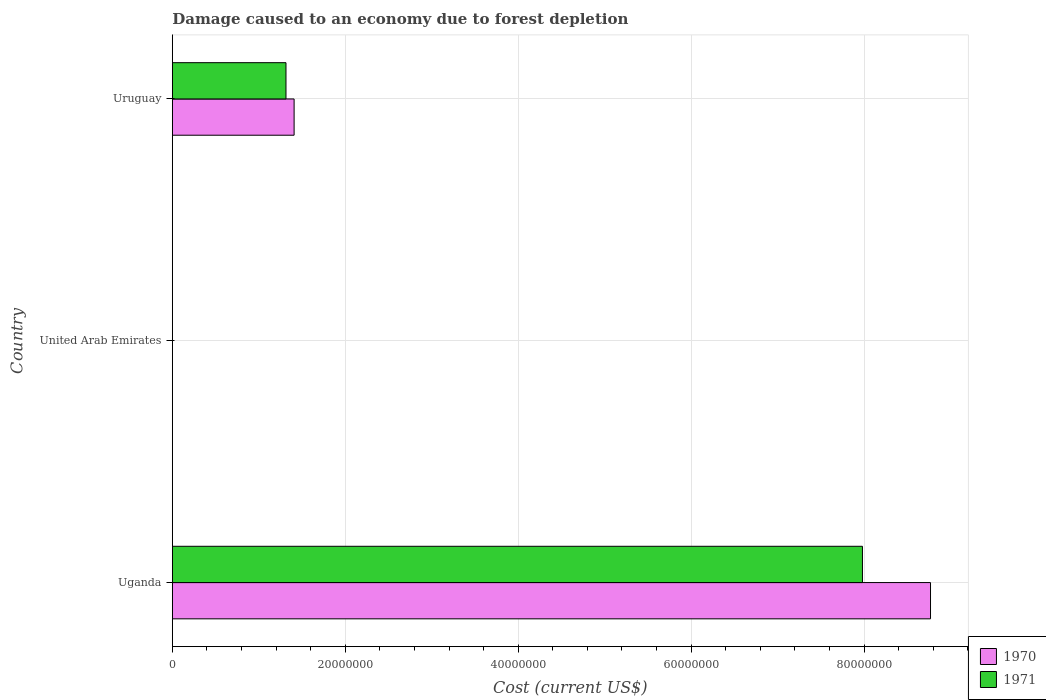Are the number of bars per tick equal to the number of legend labels?
Provide a succinct answer. Yes. Are the number of bars on each tick of the Y-axis equal?
Your answer should be very brief. Yes. How many bars are there on the 1st tick from the top?
Keep it short and to the point. 2. How many bars are there on the 2nd tick from the bottom?
Make the answer very short. 2. What is the label of the 2nd group of bars from the top?
Give a very brief answer. United Arab Emirates. In how many cases, is the number of bars for a given country not equal to the number of legend labels?
Give a very brief answer. 0. What is the cost of damage caused due to forest depletion in 1971 in Uganda?
Offer a terse response. 7.98e+07. Across all countries, what is the maximum cost of damage caused due to forest depletion in 1971?
Make the answer very short. 7.98e+07. Across all countries, what is the minimum cost of damage caused due to forest depletion in 1970?
Give a very brief answer. 5907.56. In which country was the cost of damage caused due to forest depletion in 1970 maximum?
Provide a short and direct response. Uganda. In which country was the cost of damage caused due to forest depletion in 1971 minimum?
Provide a short and direct response. United Arab Emirates. What is the total cost of damage caused due to forest depletion in 1971 in the graph?
Offer a terse response. 9.30e+07. What is the difference between the cost of damage caused due to forest depletion in 1971 in Uganda and that in United Arab Emirates?
Keep it short and to the point. 7.98e+07. What is the difference between the cost of damage caused due to forest depletion in 1971 in Uganda and the cost of damage caused due to forest depletion in 1970 in Uruguay?
Offer a terse response. 6.57e+07. What is the average cost of damage caused due to forest depletion in 1971 per country?
Keep it short and to the point. 3.10e+07. What is the difference between the cost of damage caused due to forest depletion in 1970 and cost of damage caused due to forest depletion in 1971 in Uruguay?
Make the answer very short. 9.40e+05. What is the ratio of the cost of damage caused due to forest depletion in 1970 in United Arab Emirates to that in Uruguay?
Your response must be concise. 0. Is the cost of damage caused due to forest depletion in 1970 in United Arab Emirates less than that in Uruguay?
Ensure brevity in your answer.  Yes. What is the difference between the highest and the second highest cost of damage caused due to forest depletion in 1971?
Provide a succinct answer. 6.67e+07. What is the difference between the highest and the lowest cost of damage caused due to forest depletion in 1971?
Offer a terse response. 7.98e+07. In how many countries, is the cost of damage caused due to forest depletion in 1970 greater than the average cost of damage caused due to forest depletion in 1970 taken over all countries?
Provide a short and direct response. 1. Is the sum of the cost of damage caused due to forest depletion in 1970 in Uganda and Uruguay greater than the maximum cost of damage caused due to forest depletion in 1971 across all countries?
Make the answer very short. Yes. What does the 1st bar from the top in Uganda represents?
Keep it short and to the point. 1971. What does the 2nd bar from the bottom in Uganda represents?
Offer a terse response. 1971. How many bars are there?
Ensure brevity in your answer.  6. Are all the bars in the graph horizontal?
Your response must be concise. Yes. How many countries are there in the graph?
Make the answer very short. 3. What is the difference between two consecutive major ticks on the X-axis?
Your response must be concise. 2.00e+07. Does the graph contain any zero values?
Offer a terse response. No. Where does the legend appear in the graph?
Give a very brief answer. Bottom right. How many legend labels are there?
Make the answer very short. 2. What is the title of the graph?
Provide a short and direct response. Damage caused to an economy due to forest depletion. Does "1963" appear as one of the legend labels in the graph?
Make the answer very short. No. What is the label or title of the X-axis?
Keep it short and to the point. Cost (current US$). What is the label or title of the Y-axis?
Your answer should be very brief. Country. What is the Cost (current US$) in 1970 in Uganda?
Your response must be concise. 8.77e+07. What is the Cost (current US$) in 1971 in Uganda?
Give a very brief answer. 7.98e+07. What is the Cost (current US$) in 1970 in United Arab Emirates?
Your response must be concise. 5907.56. What is the Cost (current US$) in 1971 in United Arab Emirates?
Offer a very short reply. 4897.07. What is the Cost (current US$) in 1970 in Uruguay?
Your response must be concise. 1.41e+07. What is the Cost (current US$) of 1971 in Uruguay?
Your answer should be very brief. 1.31e+07. Across all countries, what is the maximum Cost (current US$) of 1970?
Offer a terse response. 8.77e+07. Across all countries, what is the maximum Cost (current US$) of 1971?
Keep it short and to the point. 7.98e+07. Across all countries, what is the minimum Cost (current US$) of 1970?
Your answer should be compact. 5907.56. Across all countries, what is the minimum Cost (current US$) in 1971?
Offer a very short reply. 4897.07. What is the total Cost (current US$) in 1970 in the graph?
Your answer should be very brief. 1.02e+08. What is the total Cost (current US$) of 1971 in the graph?
Provide a succinct answer. 9.30e+07. What is the difference between the Cost (current US$) in 1970 in Uganda and that in United Arab Emirates?
Your response must be concise. 8.77e+07. What is the difference between the Cost (current US$) of 1971 in Uganda and that in United Arab Emirates?
Ensure brevity in your answer.  7.98e+07. What is the difference between the Cost (current US$) in 1970 in Uganda and that in Uruguay?
Give a very brief answer. 7.36e+07. What is the difference between the Cost (current US$) of 1971 in Uganda and that in Uruguay?
Make the answer very short. 6.67e+07. What is the difference between the Cost (current US$) in 1970 in United Arab Emirates and that in Uruguay?
Your answer should be compact. -1.41e+07. What is the difference between the Cost (current US$) of 1971 in United Arab Emirates and that in Uruguay?
Provide a short and direct response. -1.31e+07. What is the difference between the Cost (current US$) in 1970 in Uganda and the Cost (current US$) in 1971 in United Arab Emirates?
Offer a terse response. 8.77e+07. What is the difference between the Cost (current US$) in 1970 in Uganda and the Cost (current US$) in 1971 in Uruguay?
Provide a succinct answer. 7.46e+07. What is the difference between the Cost (current US$) of 1970 in United Arab Emirates and the Cost (current US$) of 1971 in Uruguay?
Ensure brevity in your answer.  -1.31e+07. What is the average Cost (current US$) of 1970 per country?
Your answer should be very brief. 3.39e+07. What is the average Cost (current US$) of 1971 per country?
Your response must be concise. 3.10e+07. What is the difference between the Cost (current US$) of 1970 and Cost (current US$) of 1971 in Uganda?
Your response must be concise. 7.87e+06. What is the difference between the Cost (current US$) in 1970 and Cost (current US$) in 1971 in United Arab Emirates?
Keep it short and to the point. 1010.49. What is the difference between the Cost (current US$) of 1970 and Cost (current US$) of 1971 in Uruguay?
Provide a short and direct response. 9.40e+05. What is the ratio of the Cost (current US$) in 1970 in Uganda to that in United Arab Emirates?
Provide a short and direct response. 1.48e+04. What is the ratio of the Cost (current US$) of 1971 in Uganda to that in United Arab Emirates?
Provide a short and direct response. 1.63e+04. What is the ratio of the Cost (current US$) of 1970 in Uganda to that in Uruguay?
Offer a terse response. 6.23. What is the ratio of the Cost (current US$) in 1971 in Uganda to that in Uruguay?
Your answer should be very brief. 6.07. What is the ratio of the Cost (current US$) of 1970 in United Arab Emirates to that in Uruguay?
Provide a short and direct response. 0. What is the ratio of the Cost (current US$) of 1971 in United Arab Emirates to that in Uruguay?
Provide a succinct answer. 0. What is the difference between the highest and the second highest Cost (current US$) of 1970?
Ensure brevity in your answer.  7.36e+07. What is the difference between the highest and the second highest Cost (current US$) in 1971?
Make the answer very short. 6.67e+07. What is the difference between the highest and the lowest Cost (current US$) of 1970?
Keep it short and to the point. 8.77e+07. What is the difference between the highest and the lowest Cost (current US$) in 1971?
Offer a very short reply. 7.98e+07. 